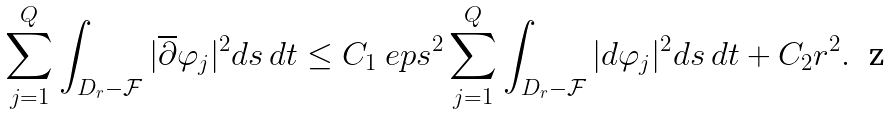Convert formula to latex. <formula><loc_0><loc_0><loc_500><loc_500>\sum _ { j = 1 } ^ { Q } \int _ { D _ { r } - \mathcal { F } } | \overline { \partial } \varphi _ { j } | ^ { 2 } d s \, d t \leq C _ { 1 } { \ e p s } ^ { 2 } \sum _ { j = 1 } ^ { Q } \int _ { D _ { r } - \mathcal { F } } | d \varphi _ { j } | ^ { 2 } d s \, d t + C _ { 2 } r ^ { 2 } .</formula> 